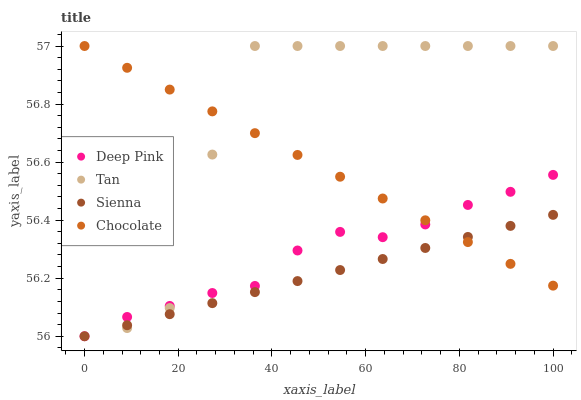Does Sienna have the minimum area under the curve?
Answer yes or no. Yes. Does Tan have the maximum area under the curve?
Answer yes or no. Yes. Does Deep Pink have the minimum area under the curve?
Answer yes or no. No. Does Deep Pink have the maximum area under the curve?
Answer yes or no. No. Is Chocolate the smoothest?
Answer yes or no. Yes. Is Tan the roughest?
Answer yes or no. Yes. Is Deep Pink the smoothest?
Answer yes or no. No. Is Deep Pink the roughest?
Answer yes or no. No. Does Sienna have the lowest value?
Answer yes or no. Yes. Does Tan have the lowest value?
Answer yes or no. No. Does Chocolate have the highest value?
Answer yes or no. Yes. Does Deep Pink have the highest value?
Answer yes or no. No. Does Chocolate intersect Deep Pink?
Answer yes or no. Yes. Is Chocolate less than Deep Pink?
Answer yes or no. No. Is Chocolate greater than Deep Pink?
Answer yes or no. No. 